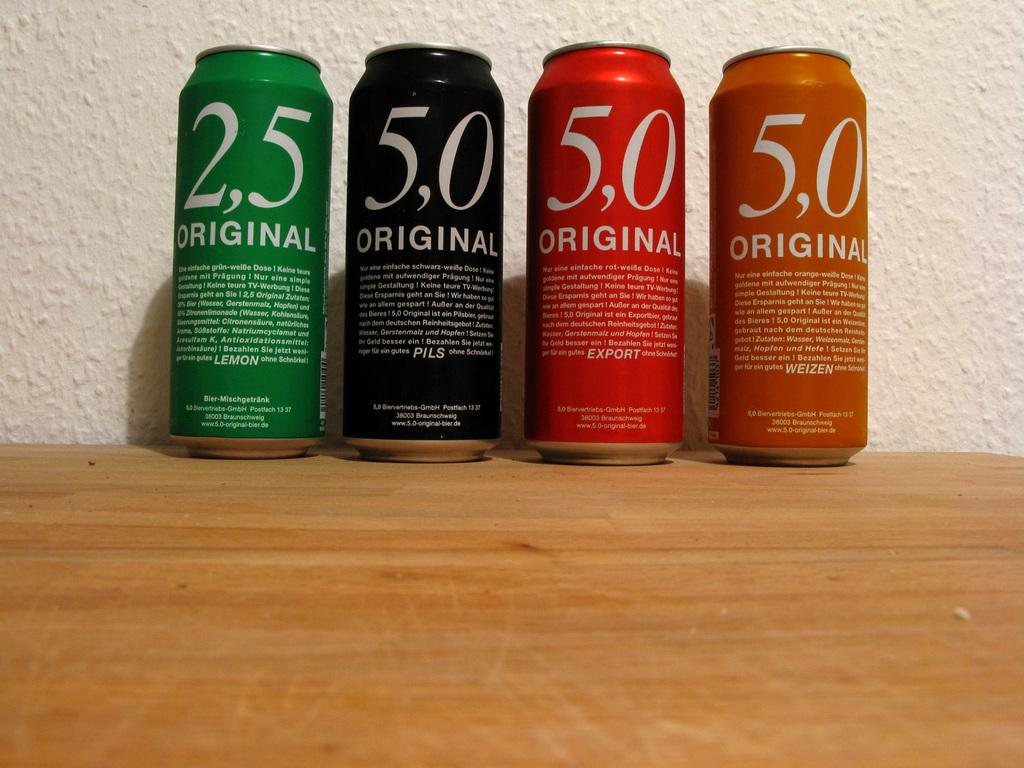Provide a one-sentence caption for the provided image. Green, Black, Red, and Orange cans sit in a row call labeled Original with their respective flavors listed in the descriptions on each can. 